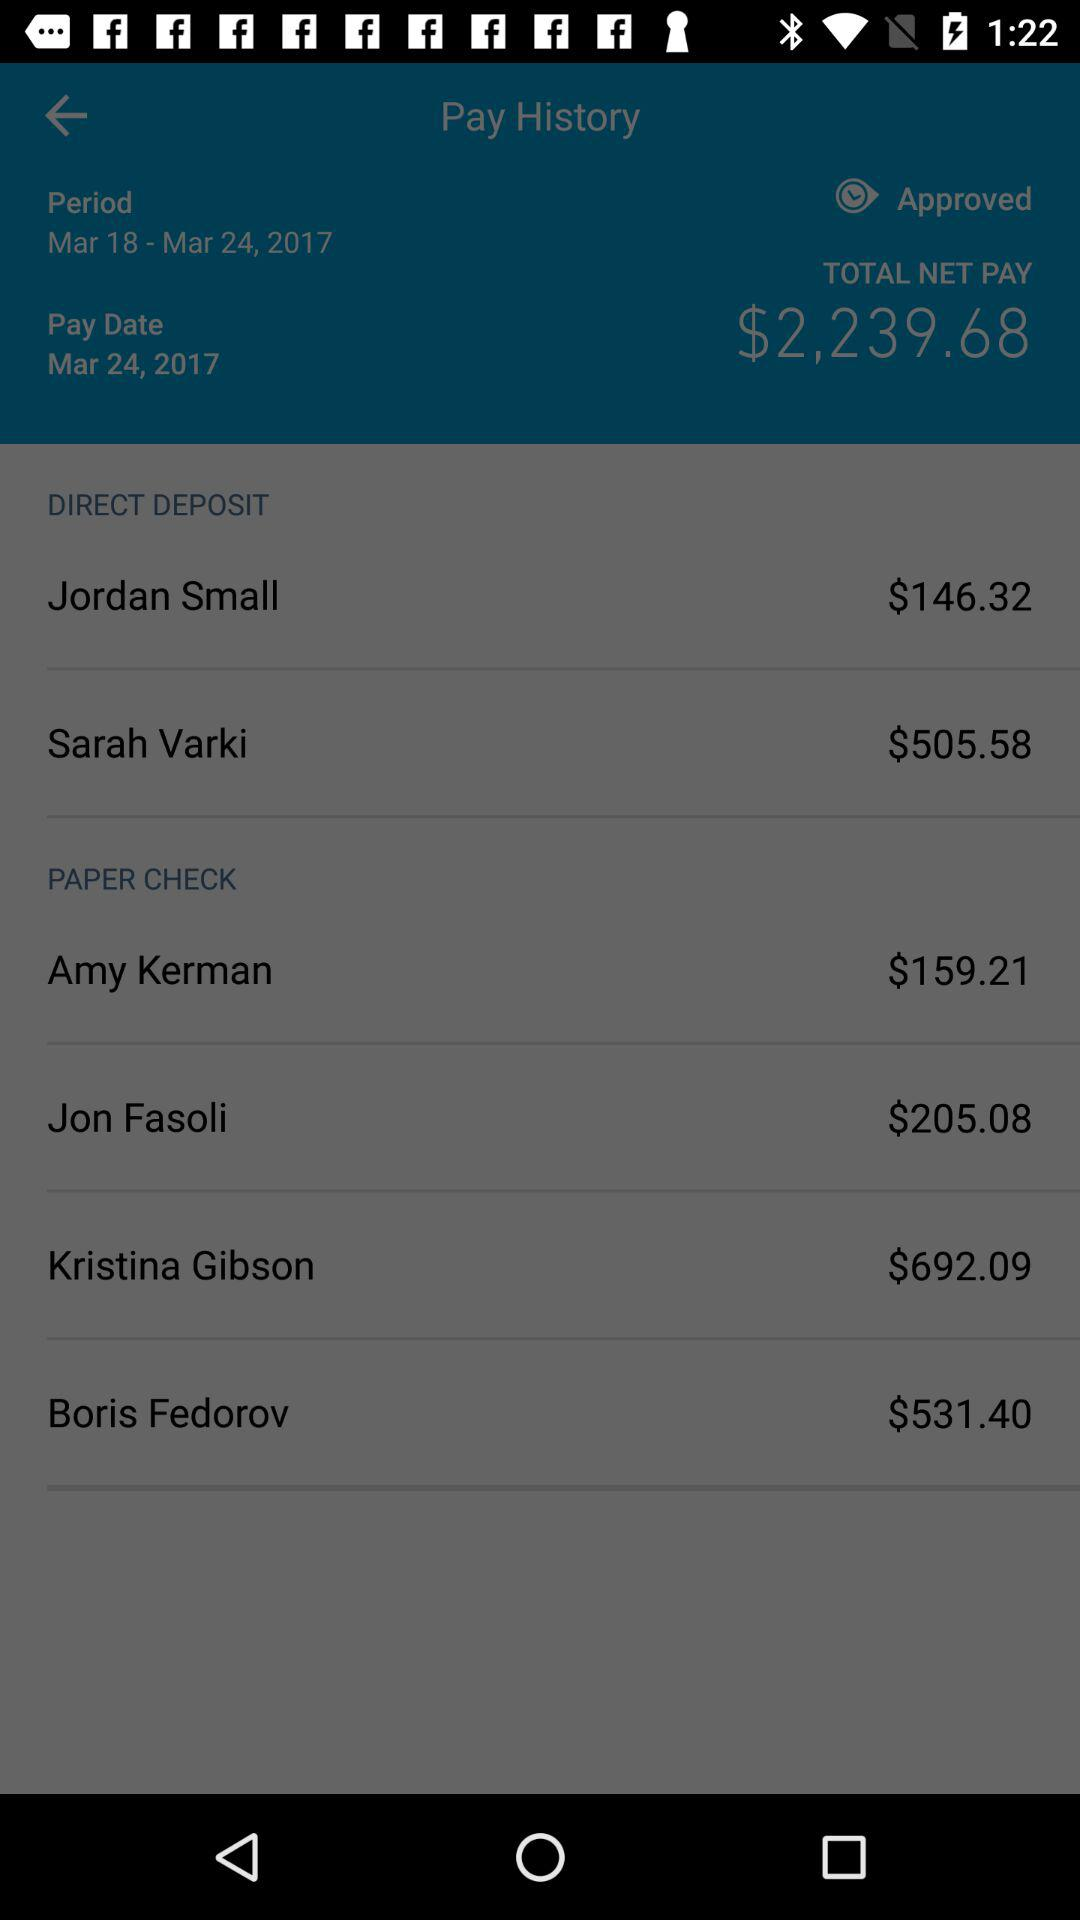What is the pay date? The pay date is March 24, 2017. 